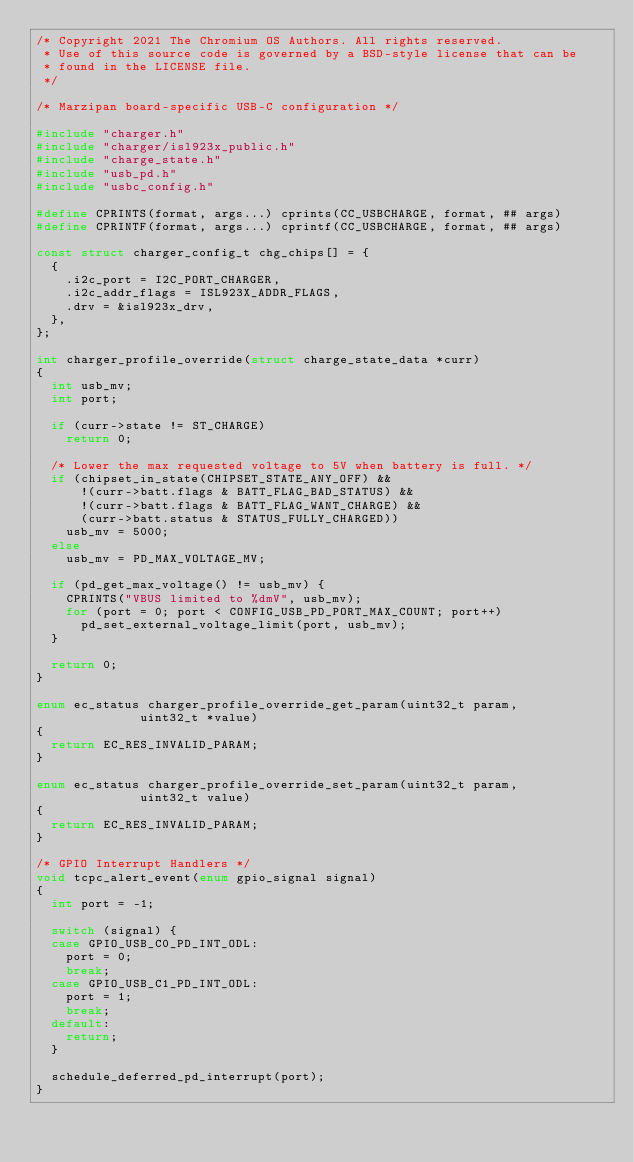<code> <loc_0><loc_0><loc_500><loc_500><_C_>/* Copyright 2021 The Chromium OS Authors. All rights reserved.
 * Use of this source code is governed by a BSD-style license that can be
 * found in the LICENSE file.
 */

/* Marzipan board-specific USB-C configuration */

#include "charger.h"
#include "charger/isl923x_public.h"
#include "charge_state.h"
#include "usb_pd.h"
#include "usbc_config.h"

#define CPRINTS(format, args...) cprints(CC_USBCHARGE, format, ## args)
#define CPRINTF(format, args...) cprintf(CC_USBCHARGE, format, ## args)

const struct charger_config_t chg_chips[] = {
	{
		.i2c_port = I2C_PORT_CHARGER,
		.i2c_addr_flags = ISL923X_ADDR_FLAGS,
		.drv = &isl923x_drv,
	},
};

int charger_profile_override(struct charge_state_data *curr)
{
	int usb_mv;
	int port;

	if (curr->state != ST_CHARGE)
		return 0;

	/* Lower the max requested voltage to 5V when battery is full. */
	if (chipset_in_state(CHIPSET_STATE_ANY_OFF) &&
	    !(curr->batt.flags & BATT_FLAG_BAD_STATUS) &&
	    !(curr->batt.flags & BATT_FLAG_WANT_CHARGE) &&
	    (curr->batt.status & STATUS_FULLY_CHARGED))
		usb_mv = 5000;
	else
		usb_mv = PD_MAX_VOLTAGE_MV;

	if (pd_get_max_voltage() != usb_mv) {
		CPRINTS("VBUS limited to %dmV", usb_mv);
		for (port = 0; port < CONFIG_USB_PD_PORT_MAX_COUNT; port++)
			pd_set_external_voltage_limit(port, usb_mv);
	}

	return 0;
}

enum ec_status charger_profile_override_get_param(uint32_t param,
						  uint32_t *value)
{
	return EC_RES_INVALID_PARAM;
}

enum ec_status charger_profile_override_set_param(uint32_t param,
						  uint32_t value)
{
	return EC_RES_INVALID_PARAM;
}

/* GPIO Interrupt Handlers */
void tcpc_alert_event(enum gpio_signal signal)
{
	int port = -1;

	switch (signal) {
	case GPIO_USB_C0_PD_INT_ODL:
		port = 0;
		break;
	case GPIO_USB_C1_PD_INT_ODL:
		port = 1;
		break;
	default:
		return;
	}

	schedule_deferred_pd_interrupt(port);
}
</code> 